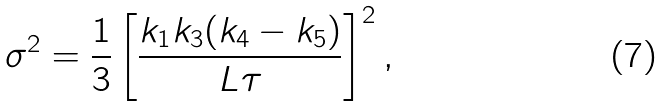<formula> <loc_0><loc_0><loc_500><loc_500>\sigma ^ { 2 } = \frac { 1 } { 3 } \left [ \frac { k _ { 1 } k _ { 3 } ( k _ { 4 } - k _ { 5 } ) } { L \tau } \right ] ^ { 2 } ,</formula> 